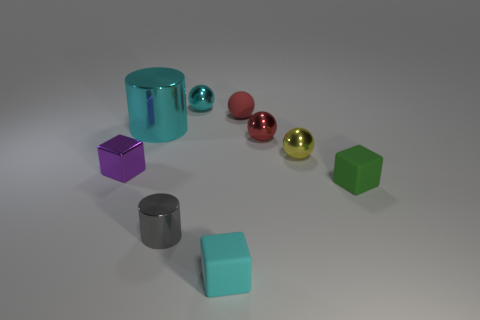Add 1 red metallic objects. How many objects exist? 10 Subtract all tiny cyan cubes. How many cubes are left? 2 Subtract all yellow cylinders. How many red balls are left? 2 Subtract all red balls. How many balls are left? 2 Subtract all cylinders. How many objects are left? 7 Subtract all purple spheres. Subtract all gray blocks. How many spheres are left? 4 Subtract all red rubber objects. Subtract all tiny green blocks. How many objects are left? 7 Add 8 large cylinders. How many large cylinders are left? 9 Add 8 big purple balls. How many big purple balls exist? 8 Subtract 1 purple blocks. How many objects are left? 8 